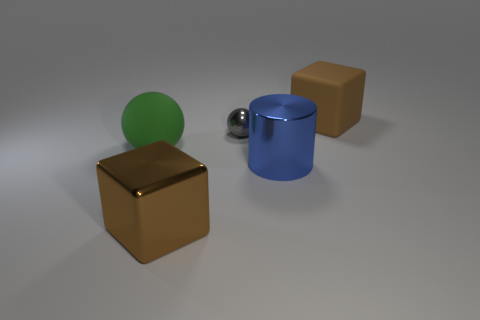There is a matte thing to the left of the large brown cube that is behind the big green rubber ball; what is its shape?
Your response must be concise. Sphere. Do the rubber sphere and the cube to the left of the small gray shiny thing have the same color?
Make the answer very short. No. There is a tiny metallic thing; what shape is it?
Your answer should be very brief. Sphere. How big is the sphere that is on the left side of the big block that is in front of the green matte object?
Your answer should be very brief. Large. Is the number of small shiny spheres that are to the right of the small gray thing the same as the number of large matte balls in front of the big green rubber thing?
Provide a short and direct response. Yes. What is the object that is in front of the large green rubber object and to the left of the small gray object made of?
Provide a short and direct response. Metal. Do the blue object and the brown cube that is on the left side of the big matte block have the same size?
Keep it short and to the point. Yes. What number of other objects are the same color as the big matte sphere?
Your answer should be compact. 0. Are there more big green rubber objects that are to the left of the large ball than small gray metal things?
Ensure brevity in your answer.  No. The matte thing right of the matte object to the left of the big object that is behind the small gray ball is what color?
Provide a short and direct response. Brown. 